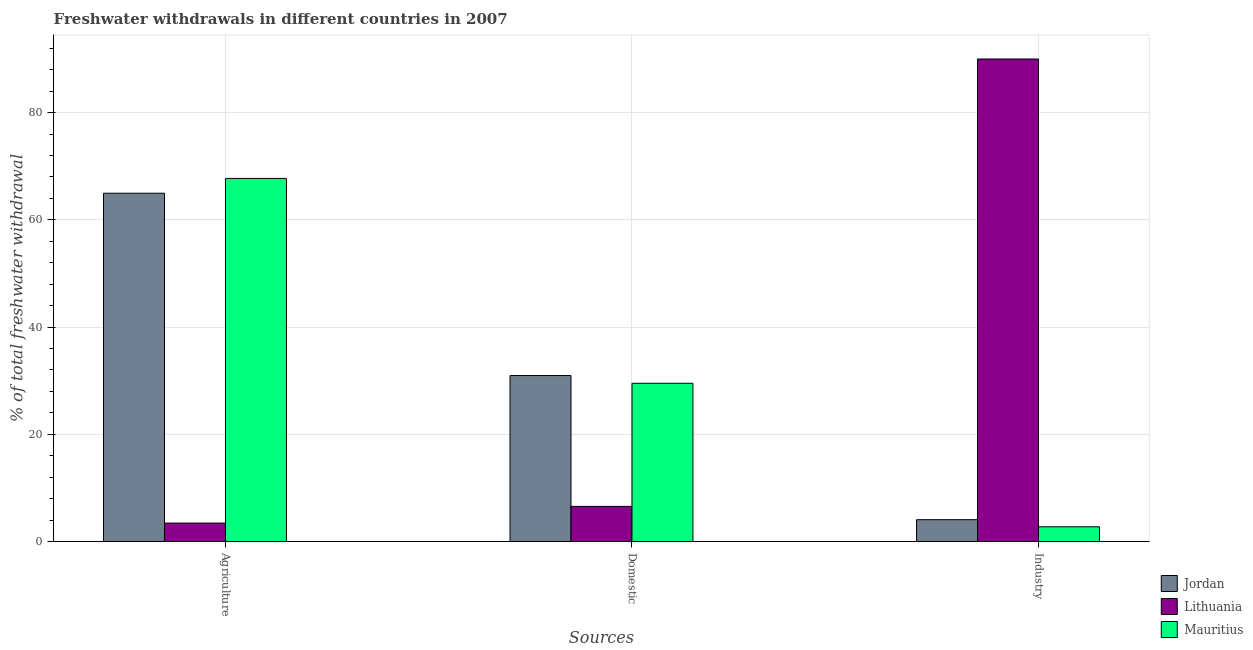How many different coloured bars are there?
Your answer should be very brief. 3. How many groups of bars are there?
Make the answer very short. 3. Are the number of bars per tick equal to the number of legend labels?
Provide a succinct answer. Yes. Are the number of bars on each tick of the X-axis equal?
Provide a succinct answer. Yes. How many bars are there on the 3rd tick from the left?
Ensure brevity in your answer.  3. What is the label of the 3rd group of bars from the left?
Offer a terse response. Industry. What is the percentage of freshwater withdrawal for agriculture in Lithuania?
Your answer should be compact. 3.45. Across all countries, what is the maximum percentage of freshwater withdrawal for industry?
Your answer should be very brief. 89.99. Across all countries, what is the minimum percentage of freshwater withdrawal for agriculture?
Your answer should be compact. 3.45. In which country was the percentage of freshwater withdrawal for industry maximum?
Make the answer very short. Lithuania. In which country was the percentage of freshwater withdrawal for industry minimum?
Ensure brevity in your answer.  Mauritius. What is the total percentage of freshwater withdrawal for domestic purposes in the graph?
Your response must be concise. 67.04. What is the difference between the percentage of freshwater withdrawal for industry in Lithuania and that in Mauritius?
Provide a short and direct response. 87.23. What is the difference between the percentage of freshwater withdrawal for domestic purposes in Mauritius and the percentage of freshwater withdrawal for agriculture in Jordan?
Your answer should be compact. -35.44. What is the average percentage of freshwater withdrawal for domestic purposes per country?
Your response must be concise. 22.35. What is the difference between the percentage of freshwater withdrawal for agriculture and percentage of freshwater withdrawal for industry in Jordan?
Your answer should be compact. 60.88. What is the ratio of the percentage of freshwater withdrawal for agriculture in Lithuania to that in Jordan?
Make the answer very short. 0.05. Is the percentage of freshwater withdrawal for domestic purposes in Jordan less than that in Mauritius?
Your answer should be very brief. No. Is the difference between the percentage of freshwater withdrawal for agriculture in Jordan and Mauritius greater than the difference between the percentage of freshwater withdrawal for industry in Jordan and Mauritius?
Your response must be concise. No. What is the difference between the highest and the second highest percentage of freshwater withdrawal for agriculture?
Your answer should be very brief. 2.76. What is the difference between the highest and the lowest percentage of freshwater withdrawal for domestic purposes?
Make the answer very short. 24.4. What does the 2nd bar from the left in Industry represents?
Give a very brief answer. Lithuania. What does the 3rd bar from the right in Industry represents?
Provide a short and direct response. Jordan. Is it the case that in every country, the sum of the percentage of freshwater withdrawal for agriculture and percentage of freshwater withdrawal for domestic purposes is greater than the percentage of freshwater withdrawal for industry?
Provide a succinct answer. No. Are all the bars in the graph horizontal?
Offer a very short reply. No. What is the difference between two consecutive major ticks on the Y-axis?
Give a very brief answer. 20. Are the values on the major ticks of Y-axis written in scientific E-notation?
Keep it short and to the point. No. Does the graph contain any zero values?
Offer a terse response. No. Does the graph contain grids?
Your answer should be very brief. Yes. How are the legend labels stacked?
Keep it short and to the point. Vertical. What is the title of the graph?
Provide a succinct answer. Freshwater withdrawals in different countries in 2007. Does "Small states" appear as one of the legend labels in the graph?
Offer a terse response. No. What is the label or title of the X-axis?
Ensure brevity in your answer.  Sources. What is the label or title of the Y-axis?
Your answer should be very brief. % of total freshwater withdrawal. What is the % of total freshwater withdrawal of Jordan in Agriculture?
Your answer should be compact. 64.96. What is the % of total freshwater withdrawal in Lithuania in Agriculture?
Make the answer very short. 3.45. What is the % of total freshwater withdrawal in Mauritius in Agriculture?
Offer a very short reply. 67.72. What is the % of total freshwater withdrawal in Jordan in Domestic?
Keep it short and to the point. 30.96. What is the % of total freshwater withdrawal in Lithuania in Domestic?
Ensure brevity in your answer.  6.56. What is the % of total freshwater withdrawal in Mauritius in Domestic?
Ensure brevity in your answer.  29.52. What is the % of total freshwater withdrawal of Jordan in Industry?
Offer a very short reply. 4.08. What is the % of total freshwater withdrawal of Lithuania in Industry?
Give a very brief answer. 89.99. What is the % of total freshwater withdrawal of Mauritius in Industry?
Keep it short and to the point. 2.76. Across all Sources, what is the maximum % of total freshwater withdrawal in Jordan?
Make the answer very short. 64.96. Across all Sources, what is the maximum % of total freshwater withdrawal in Lithuania?
Your response must be concise. 89.99. Across all Sources, what is the maximum % of total freshwater withdrawal in Mauritius?
Your response must be concise. 67.72. Across all Sources, what is the minimum % of total freshwater withdrawal of Jordan?
Provide a succinct answer. 4.08. Across all Sources, what is the minimum % of total freshwater withdrawal in Lithuania?
Give a very brief answer. 3.45. Across all Sources, what is the minimum % of total freshwater withdrawal of Mauritius?
Ensure brevity in your answer.  2.76. What is the total % of total freshwater withdrawal of Jordan in the graph?
Give a very brief answer. 100. What is the total % of total freshwater withdrawal of Lithuania in the graph?
Provide a short and direct response. 100. What is the total % of total freshwater withdrawal of Mauritius in the graph?
Make the answer very short. 100. What is the difference between the % of total freshwater withdrawal of Lithuania in Agriculture and that in Domestic?
Your response must be concise. -3.11. What is the difference between the % of total freshwater withdrawal of Mauritius in Agriculture and that in Domestic?
Provide a succinct answer. 38.2. What is the difference between the % of total freshwater withdrawal of Jordan in Agriculture and that in Industry?
Provide a succinct answer. 60.88. What is the difference between the % of total freshwater withdrawal of Lithuania in Agriculture and that in Industry?
Provide a succinct answer. -86.54. What is the difference between the % of total freshwater withdrawal of Mauritius in Agriculture and that in Industry?
Give a very brief answer. 64.96. What is the difference between the % of total freshwater withdrawal in Jordan in Domestic and that in Industry?
Your response must be concise. 26.88. What is the difference between the % of total freshwater withdrawal of Lithuania in Domestic and that in Industry?
Provide a short and direct response. -83.43. What is the difference between the % of total freshwater withdrawal in Mauritius in Domestic and that in Industry?
Provide a short and direct response. 26.76. What is the difference between the % of total freshwater withdrawal in Jordan in Agriculture and the % of total freshwater withdrawal in Lithuania in Domestic?
Provide a short and direct response. 58.4. What is the difference between the % of total freshwater withdrawal in Jordan in Agriculture and the % of total freshwater withdrawal in Mauritius in Domestic?
Offer a terse response. 35.44. What is the difference between the % of total freshwater withdrawal in Lithuania in Agriculture and the % of total freshwater withdrawal in Mauritius in Domestic?
Your response must be concise. -26.07. What is the difference between the % of total freshwater withdrawal of Jordan in Agriculture and the % of total freshwater withdrawal of Lithuania in Industry?
Ensure brevity in your answer.  -25.03. What is the difference between the % of total freshwater withdrawal in Jordan in Agriculture and the % of total freshwater withdrawal in Mauritius in Industry?
Offer a terse response. 62.2. What is the difference between the % of total freshwater withdrawal in Lithuania in Agriculture and the % of total freshwater withdrawal in Mauritius in Industry?
Provide a short and direct response. 0.69. What is the difference between the % of total freshwater withdrawal of Jordan in Domestic and the % of total freshwater withdrawal of Lithuania in Industry?
Your answer should be very brief. -59.03. What is the difference between the % of total freshwater withdrawal of Jordan in Domestic and the % of total freshwater withdrawal of Mauritius in Industry?
Your response must be concise. 28.2. What is the difference between the % of total freshwater withdrawal of Lithuania in Domestic and the % of total freshwater withdrawal of Mauritius in Industry?
Ensure brevity in your answer.  3.8. What is the average % of total freshwater withdrawal of Jordan per Sources?
Offer a very short reply. 33.33. What is the average % of total freshwater withdrawal of Lithuania per Sources?
Offer a very short reply. 33.33. What is the average % of total freshwater withdrawal of Mauritius per Sources?
Keep it short and to the point. 33.33. What is the difference between the % of total freshwater withdrawal in Jordan and % of total freshwater withdrawal in Lithuania in Agriculture?
Offer a terse response. 61.51. What is the difference between the % of total freshwater withdrawal in Jordan and % of total freshwater withdrawal in Mauritius in Agriculture?
Provide a short and direct response. -2.76. What is the difference between the % of total freshwater withdrawal of Lithuania and % of total freshwater withdrawal of Mauritius in Agriculture?
Offer a terse response. -64.27. What is the difference between the % of total freshwater withdrawal of Jordan and % of total freshwater withdrawal of Lithuania in Domestic?
Provide a short and direct response. 24.4. What is the difference between the % of total freshwater withdrawal of Jordan and % of total freshwater withdrawal of Mauritius in Domestic?
Make the answer very short. 1.44. What is the difference between the % of total freshwater withdrawal in Lithuania and % of total freshwater withdrawal in Mauritius in Domestic?
Offer a very short reply. -22.96. What is the difference between the % of total freshwater withdrawal of Jordan and % of total freshwater withdrawal of Lithuania in Industry?
Your answer should be compact. -85.91. What is the difference between the % of total freshwater withdrawal of Jordan and % of total freshwater withdrawal of Mauritius in Industry?
Make the answer very short. 1.32. What is the difference between the % of total freshwater withdrawal in Lithuania and % of total freshwater withdrawal in Mauritius in Industry?
Your response must be concise. 87.23. What is the ratio of the % of total freshwater withdrawal in Jordan in Agriculture to that in Domestic?
Keep it short and to the point. 2.1. What is the ratio of the % of total freshwater withdrawal of Lithuania in Agriculture to that in Domestic?
Offer a terse response. 0.53. What is the ratio of the % of total freshwater withdrawal in Mauritius in Agriculture to that in Domestic?
Provide a succinct answer. 2.29. What is the ratio of the % of total freshwater withdrawal of Jordan in Agriculture to that in Industry?
Offer a terse response. 15.92. What is the ratio of the % of total freshwater withdrawal of Lithuania in Agriculture to that in Industry?
Provide a succinct answer. 0.04. What is the ratio of the % of total freshwater withdrawal in Mauritius in Agriculture to that in Industry?
Your response must be concise. 24.55. What is the ratio of the % of total freshwater withdrawal of Jordan in Domestic to that in Industry?
Make the answer very short. 7.59. What is the ratio of the % of total freshwater withdrawal in Lithuania in Domestic to that in Industry?
Make the answer very short. 0.07. What is the ratio of the % of total freshwater withdrawal in Mauritius in Domestic to that in Industry?
Your answer should be compact. 10.7. What is the difference between the highest and the second highest % of total freshwater withdrawal in Jordan?
Your response must be concise. 34. What is the difference between the highest and the second highest % of total freshwater withdrawal of Lithuania?
Give a very brief answer. 83.43. What is the difference between the highest and the second highest % of total freshwater withdrawal in Mauritius?
Your response must be concise. 38.2. What is the difference between the highest and the lowest % of total freshwater withdrawal of Jordan?
Provide a short and direct response. 60.88. What is the difference between the highest and the lowest % of total freshwater withdrawal of Lithuania?
Your answer should be compact. 86.54. What is the difference between the highest and the lowest % of total freshwater withdrawal in Mauritius?
Make the answer very short. 64.96. 